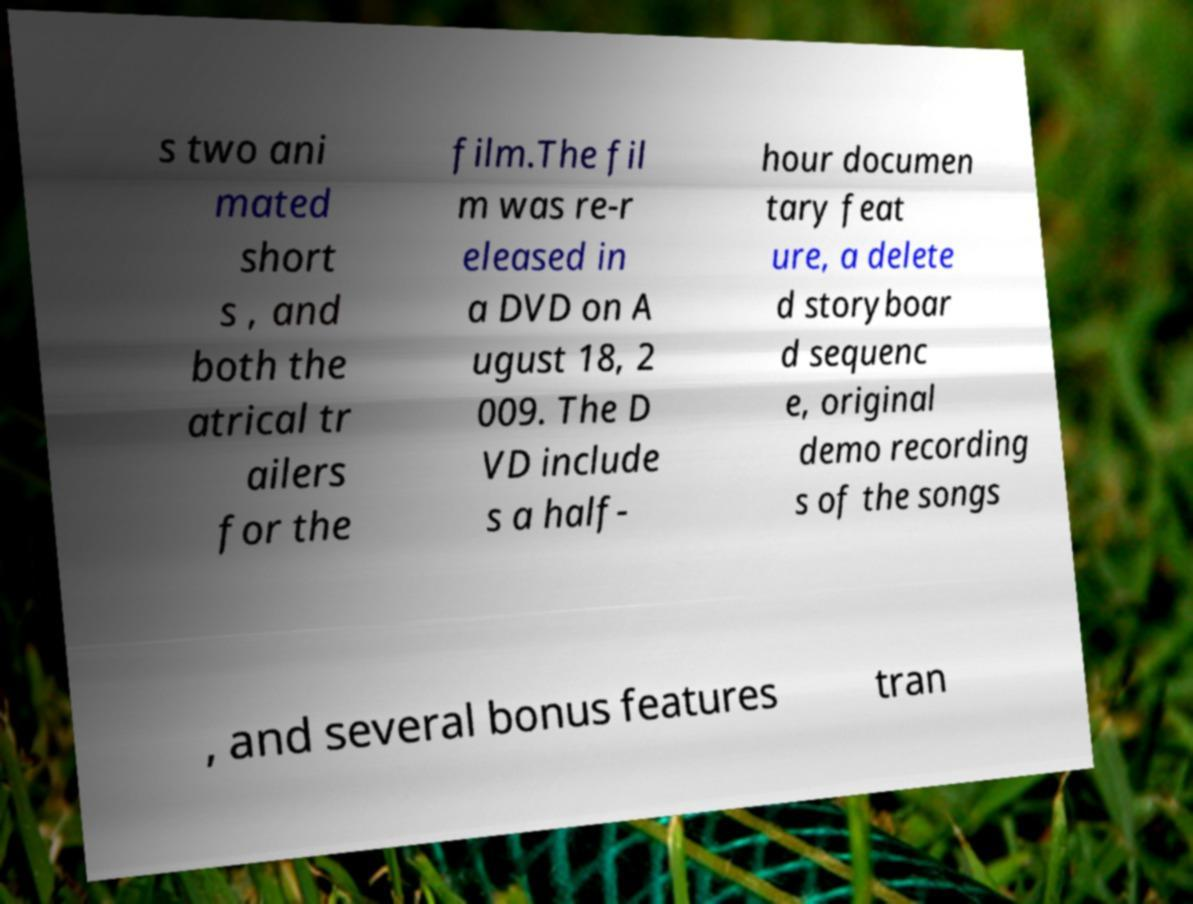Can you read and provide the text displayed in the image?This photo seems to have some interesting text. Can you extract and type it out for me? s two ani mated short s , and both the atrical tr ailers for the film.The fil m was re-r eleased in a DVD on A ugust 18, 2 009. The D VD include s a half- hour documen tary feat ure, a delete d storyboar d sequenc e, original demo recording s of the songs , and several bonus features tran 